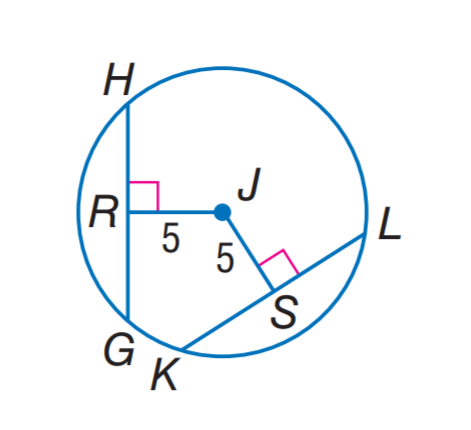Answer the mathemtical geometry problem and directly provide the correct option letter.
Question: In \odot J, G H = 9 and K L = 4 x + 1. Find x.
Choices: A: 2 B: 3 C: 5 D: 9 A 